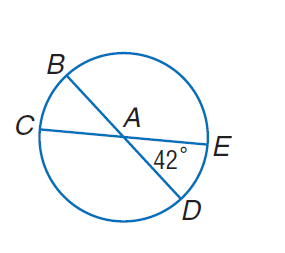Question: In \odot A, m \angle E A D = 42. Find m \widehat B C.
Choices:
A. 42
B. 48
C. 52
D. 108
Answer with the letter. Answer: A Question: In \odot A, m \angle E A D = 42. Find m \widehat C B E.
Choices:
A. 90
B. 180
C. 270
D. 360
Answer with the letter. Answer: B Question: In \odot A, m \angle E A D = 42. Find m \widehat E D B.
Choices:
A. 120
B. 138
C. 222
D. 240
Answer with the letter. Answer: C Question: In \odot A, m \angle E A D = 42. Find m \widehat C D.
Choices:
A. 138
B. 142
C. 240
D. 360
Answer with the letter. Answer: A 